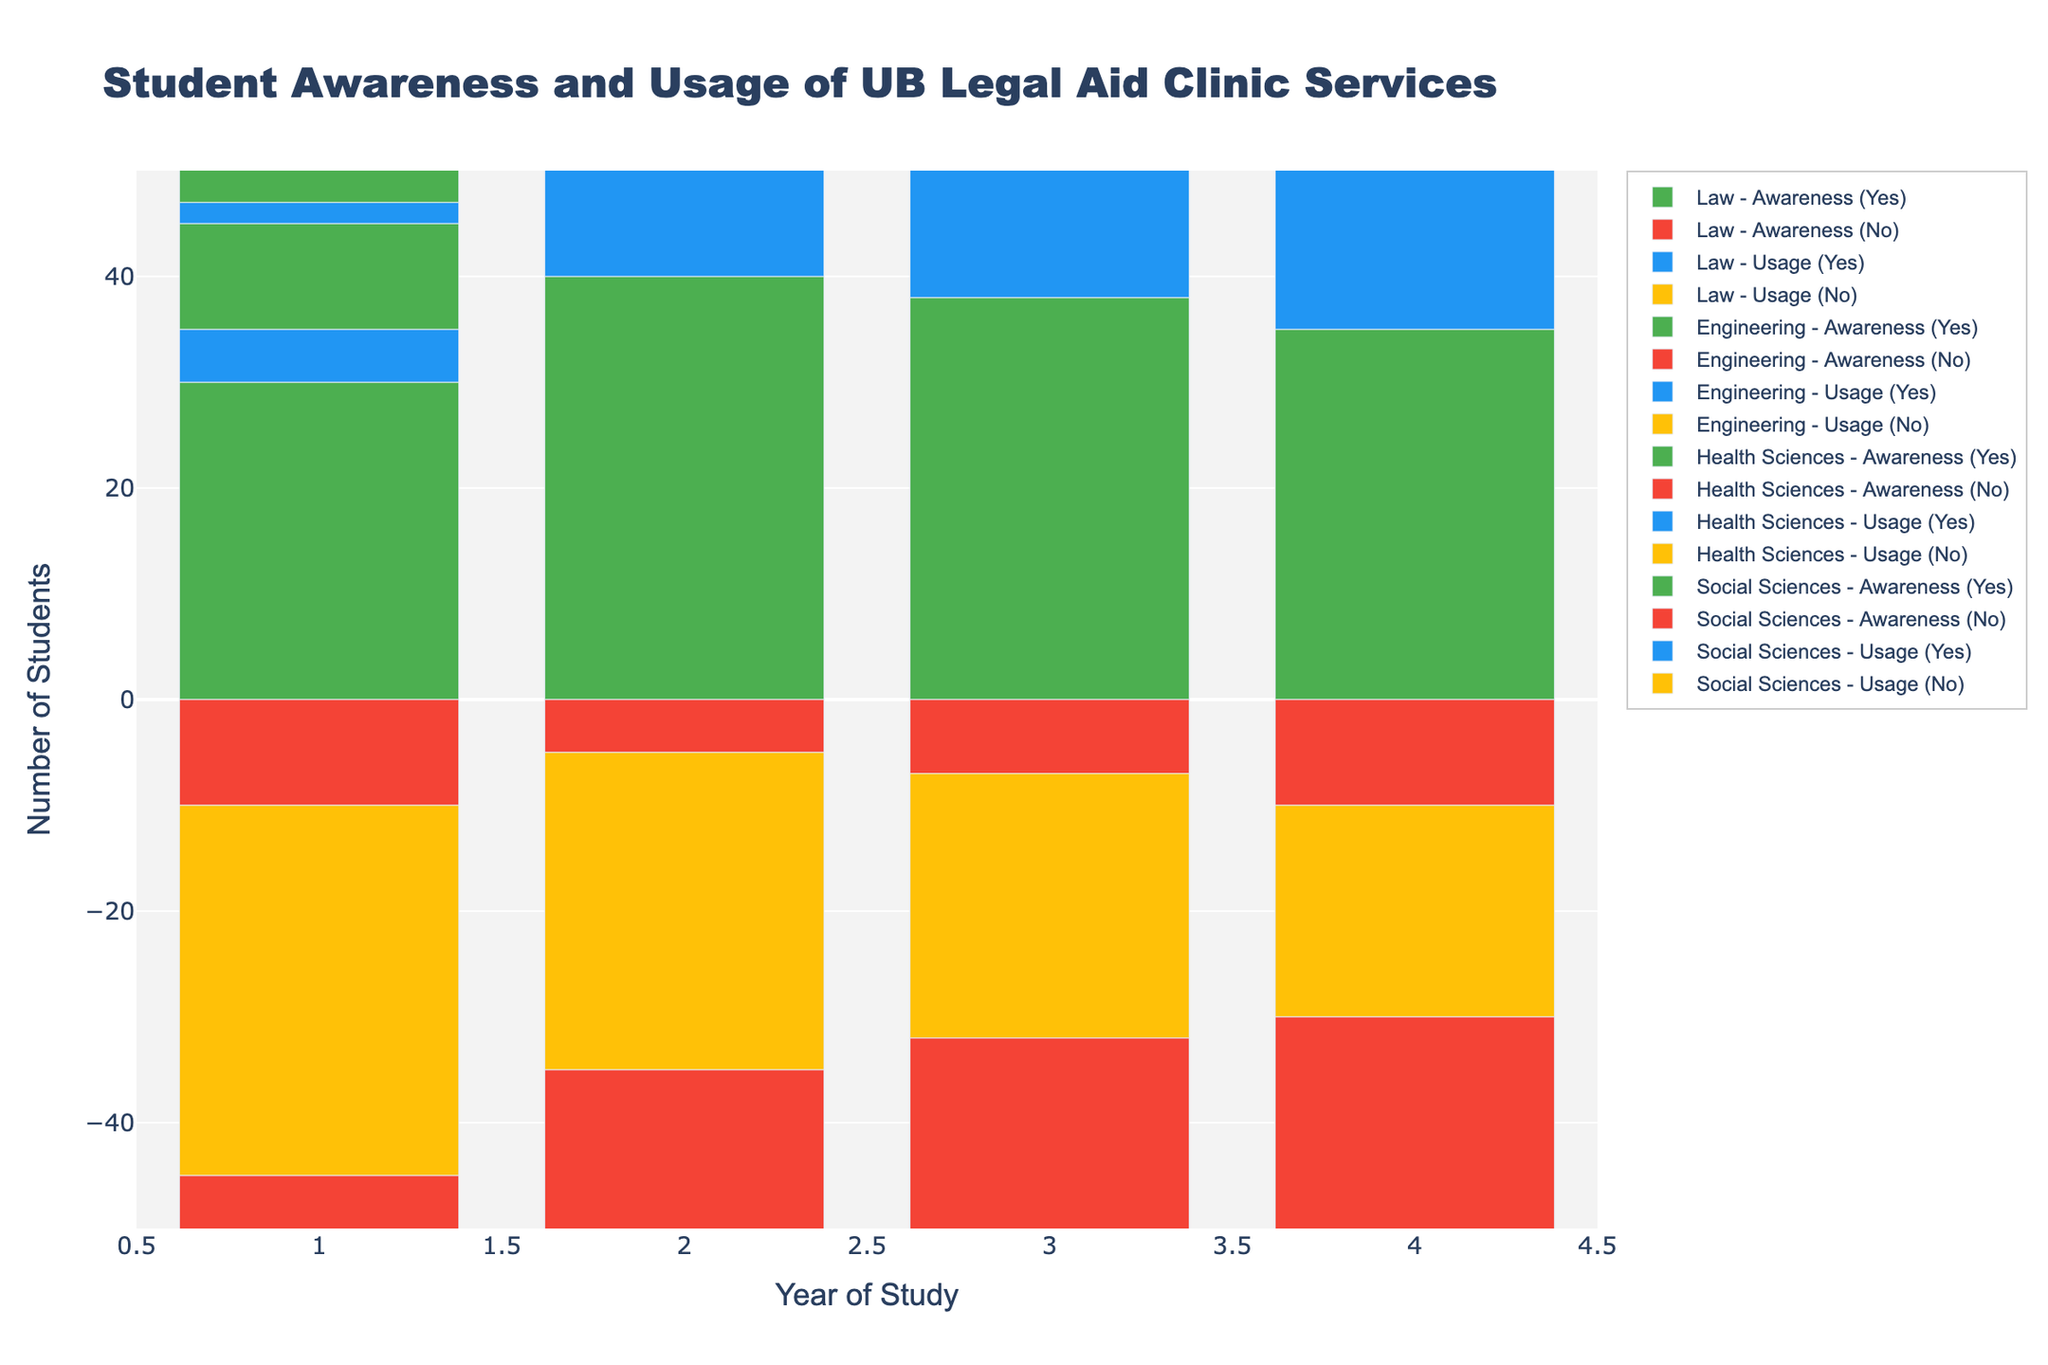What's the general trend of awareness among Law students from Year 1 to Year 4? By looking at the bars representing "Awareness (Yes)" and "Awareness (No)" for Law students across Year 1 to Year 4, we can observe that the number of students aware of the service increases initially from Year 1 (30) to Year 2 (40), slightly drops in Year 3 (38) and Year 4 (35). The number of students unaware of the service generally decreases from Year 1 (10) to Year 4 (10) with minor fluctuations.
Answer: Increasing then slightly decreasing Which faculty had the highest proportion of "Awareness (No)" in Year 1? In Year 1, observe the negative bar heights for "Awareness (No)" for each faculty. Law had -10, Engineering had -40, Health Sciences had -28, and Social Sciences had -32. Engineering had the highest proportion of students unaware of the clinic.
Answer: Engineering Compare the usage of the Legal Aid Clinic services by Year 3 students across all faculties. Which faculty had the highest usage? To find this, compare the bars representing "Usage (Yes)" for Year 3 across all faculties. Law had 20, Engineering had 10, Health Sciences had 15, and Social Sciences had 12. Law faculty had the highest usage.
Answer: Law What is the total number of students in Year 4 across all faculties who are aware of the Legal Aid Clinic services? Add up the positive bars representing "Awareness (Yes)" for Year 4 across all faculties: Law (35) + Engineering (20) + Health Sciences (28) + Social Sciences (30) = 113.
Answer: 113 Which year had the lowest awareness among Health Sciences students? Compare the positive bar heights for "Awareness (Yes)" for Health Sciences across all years. Year 1 (22), Year 2 (25), Year 3 (30), and Year 4 (28). Year 1 had the lowest awareness.
Answer: Year 1 How does the usage of services change from Year 2 to Year 3 for Engineering students? Look at the positive bars for "Usage (Yes)" in Year 2 (5) and Year 3 (10) for Engineering students. The usage increased from Year 2 to Year 3.
Answer: Increased Across all faculties, which year of study showed the lowest usage of the clinic services? Compare the positive bar heights for "Usage (Yes)" across all years and faculties. Year 1 of Engineering had the lowest usage with only 2 students.
Answer: Engineering Year 1 What is the difference in the number of Law students who are aware of the clinic's services between Year 2 and Year 4? Look at the positive bar heights for "Awareness (Yes)" for Law students in Year 2 (40) and Year 4 (35). The difference is 40 - 35 = 5.
Answer: 5 How does the number of Social Sciences students using the services change from Year 1 to Year 4? Look at the positive bar heights for "Usage (Yes)" in Year 1 (6) and Year 4 (15) for Social Sciences students. There is an increase in the number of users.
Answer: Increased 